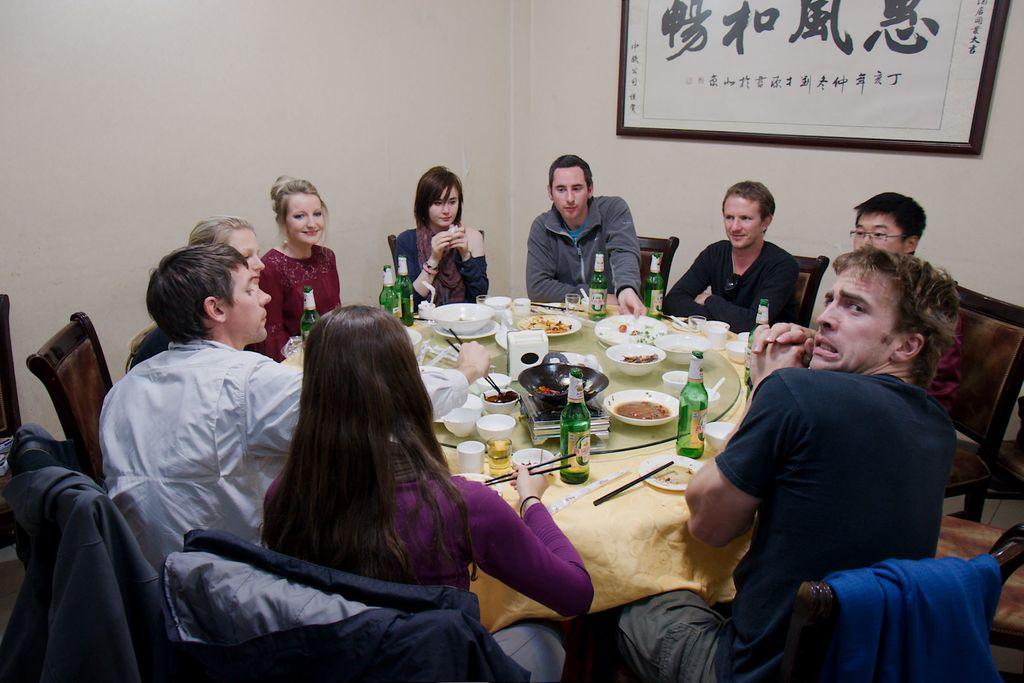How many people are in the image? There is a group of people in the image, but the exact number is not specified. Where are the people located in the image? The people are gathered at a table in the image. What are the people doing at the table? The people are having food in the image. What type of cattle can be seen grazing near the dock in the image? There is no mention of cattle or a dock in the image; it features a group of people gathered at a table having food. 